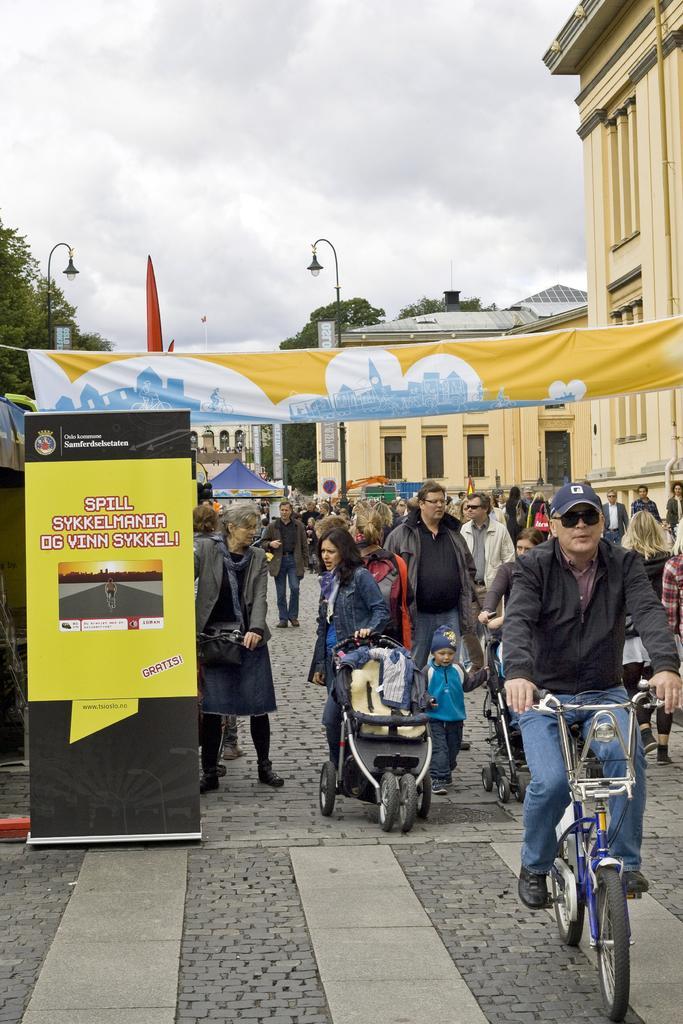Please provide a concise description of this image. In the picture we can see a public and a man riding a bicycle he is wearing a cap, black glasses and black jacket. In the background we can see a buildings, trees, and sky with street light. 